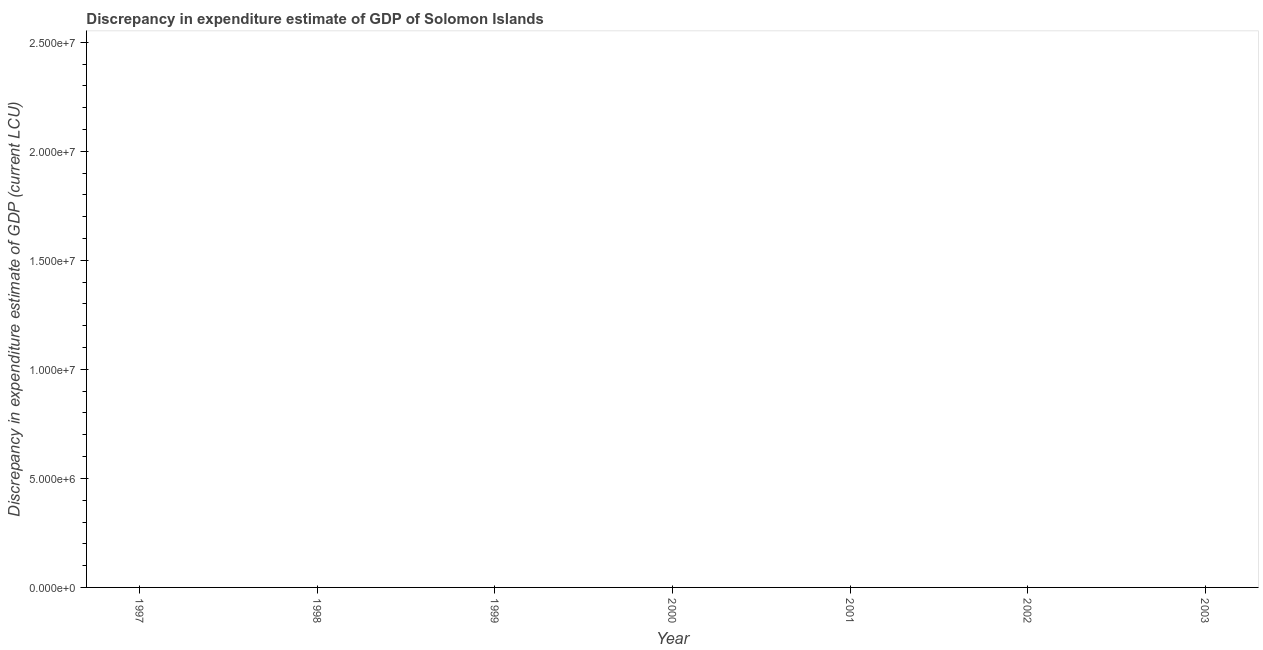What is the discrepancy in expenditure estimate of gdp in 2000?
Offer a terse response. 0. Across all years, what is the minimum discrepancy in expenditure estimate of gdp?
Offer a terse response. 0. What is the average discrepancy in expenditure estimate of gdp per year?
Your answer should be very brief. 0. In how many years, is the discrepancy in expenditure estimate of gdp greater than 16000000 LCU?
Offer a terse response. 0. In how many years, is the discrepancy in expenditure estimate of gdp greater than the average discrepancy in expenditure estimate of gdp taken over all years?
Keep it short and to the point. 0. How many dotlines are there?
Provide a succinct answer. 0. Does the graph contain any zero values?
Provide a succinct answer. Yes. Does the graph contain grids?
Keep it short and to the point. No. What is the title of the graph?
Give a very brief answer. Discrepancy in expenditure estimate of GDP of Solomon Islands. What is the label or title of the Y-axis?
Your answer should be very brief. Discrepancy in expenditure estimate of GDP (current LCU). What is the Discrepancy in expenditure estimate of GDP (current LCU) in 1997?
Give a very brief answer. 0. What is the Discrepancy in expenditure estimate of GDP (current LCU) in 1999?
Offer a terse response. 0. What is the Discrepancy in expenditure estimate of GDP (current LCU) in 2000?
Make the answer very short. 0. What is the Discrepancy in expenditure estimate of GDP (current LCU) in 2001?
Offer a terse response. 0. What is the Discrepancy in expenditure estimate of GDP (current LCU) in 2003?
Provide a short and direct response. 0. 